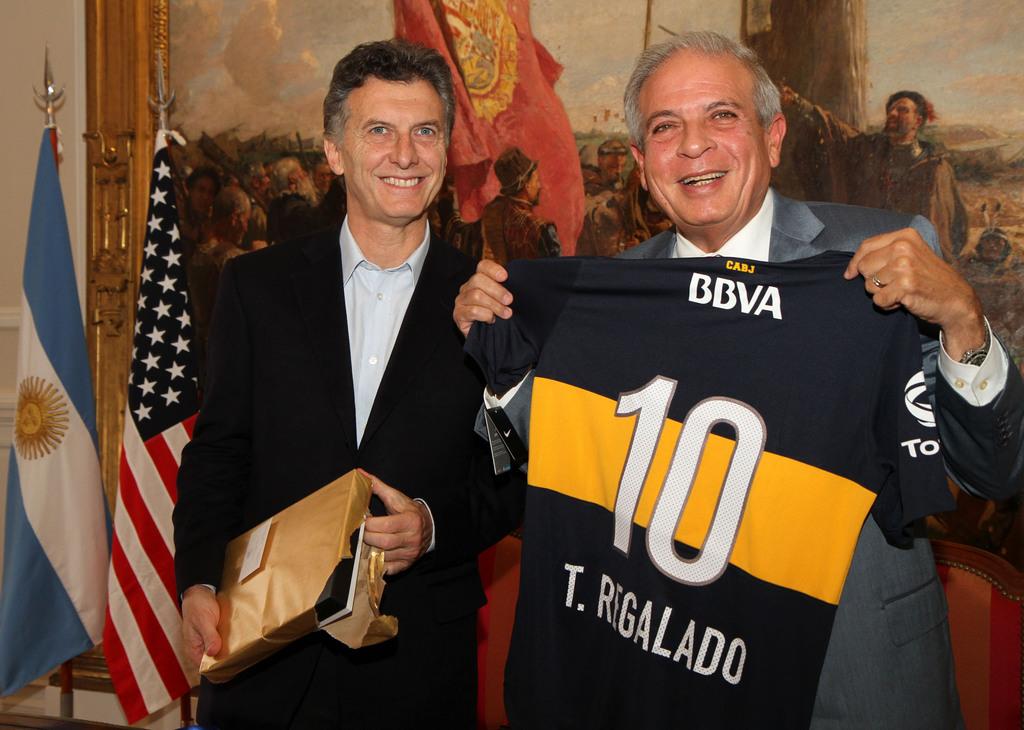What is the jersey number the man is holding?
Provide a short and direct response. 10. Are both men smiling in this picture?
Your answer should be very brief. Answering does not require reading text in the image. 